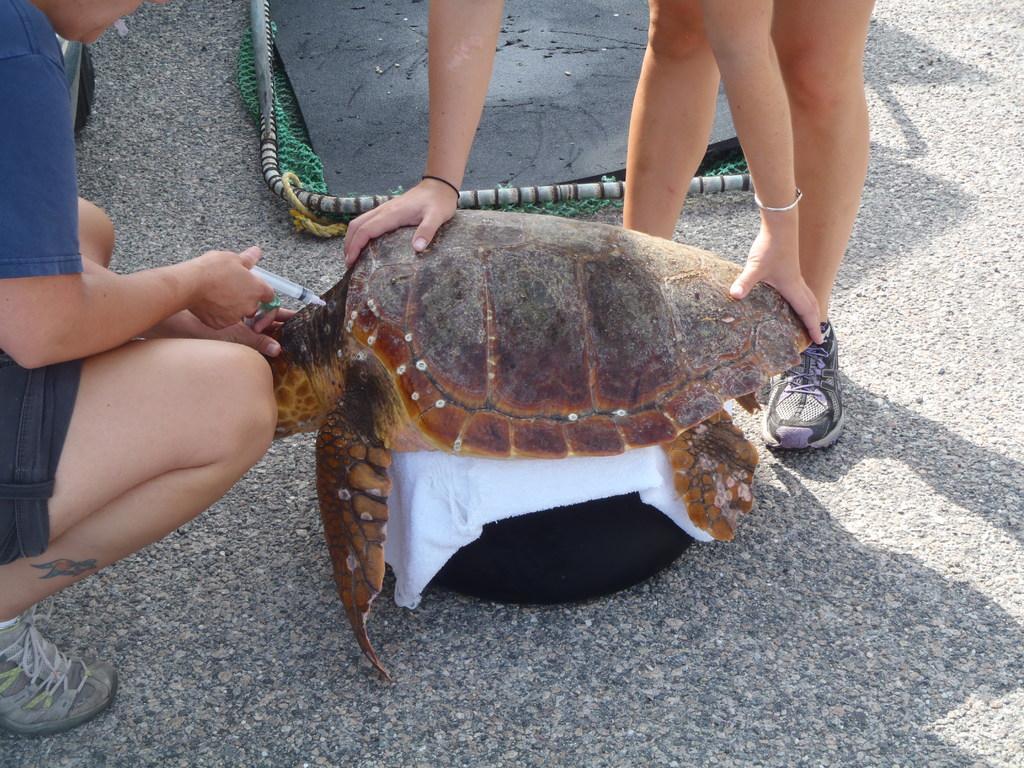Please provide a concise description of this image. In this picture, there is a turtle in the center which is placed on the road. Towards the left, there is a man giving the injection to the turtle and there is another woman holding the turtle. 